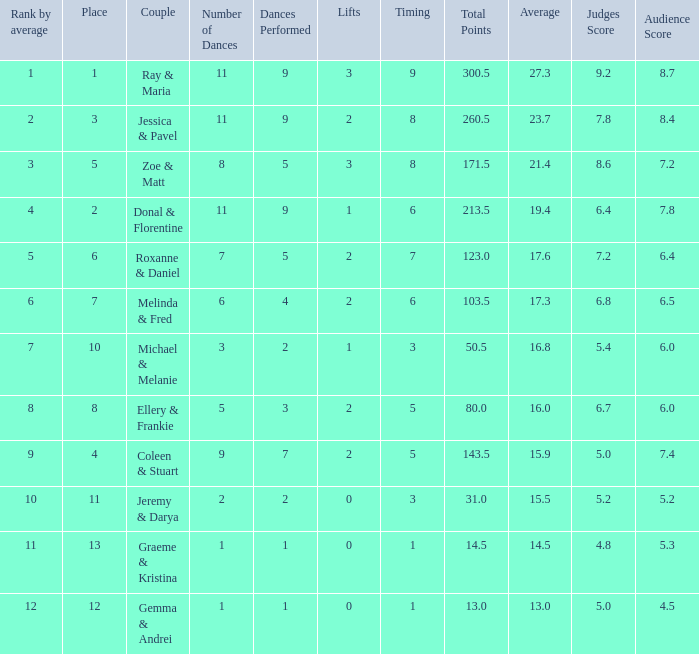What place would you be in if your rank by average is less than 2.0? 1.0. 